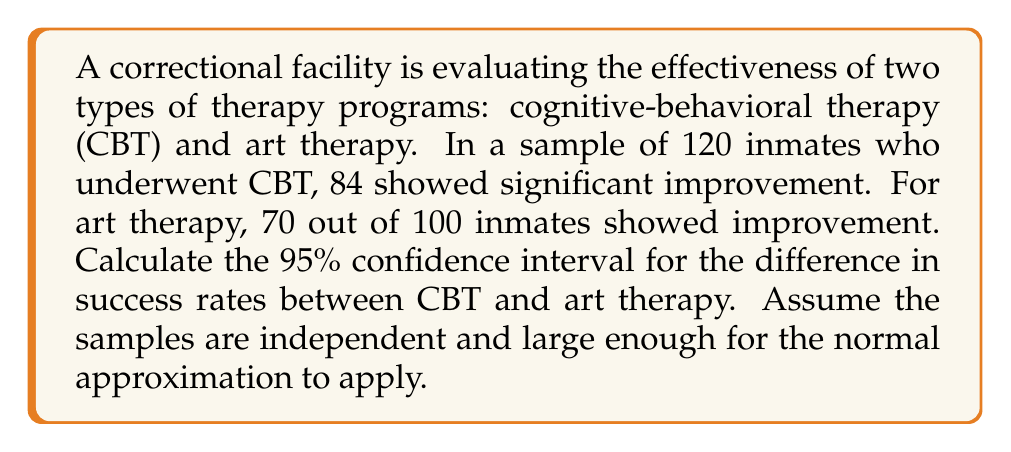Help me with this question. Let's approach this step-by-step:

1) First, calculate the sample proportions for each therapy:
   CBT: $\hat{p}_1 = 84/120 = 0.7$
   Art Therapy: $\hat{p}_2 = 70/100 = 0.7$

2) The difference in sample proportions is:
   $\hat{p}_1 - \hat{p}_2 = 0.7 - 0.7 = 0$

3) Calculate the standard error of the difference:
   $SE = \sqrt{\frac{\hat{p}_1(1-\hat{p}_1)}{n_1} + \frac{\hat{p}_2(1-\hat{p}_2)}{n_2}}$
   $SE = \sqrt{\frac{0.7(1-0.7)}{120} + \frac{0.7(1-0.7)}{100}}$
   $SE = \sqrt{0.001458333 + 0.00175} = \sqrt{0.003208333} = 0.0566$

4) For a 95% confidence interval, use z = 1.96

5) The confidence interval is calculated as:
   $(\hat{p}_1 - \hat{p}_2) \pm z \cdot SE$
   $0 \pm 1.96 \cdot 0.0566$
   $0 \pm 0.111$

6) Therefore, the 95% confidence interval is (-0.111, 0.111)

This interval includes 0, suggesting that there may not be a significant difference between the success rates of the two therapies at the 95% confidence level.
Answer: (-0.111, 0.111) 